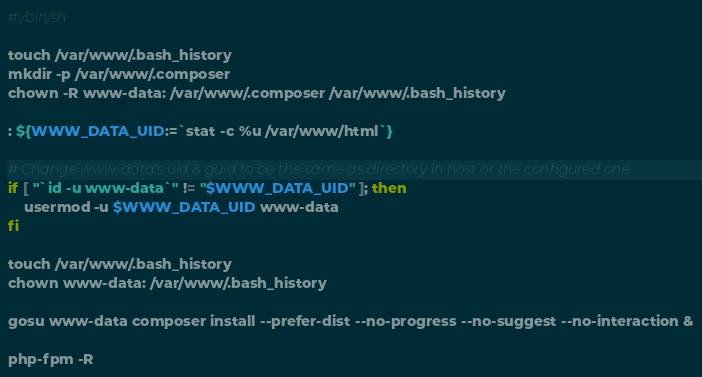Convert code to text. <code><loc_0><loc_0><loc_500><loc_500><_Bash_>#!/bin/sh

touch /var/www/.bash_history
mkdir -p /var/www/.composer
chown -R www-data: /var/www/.composer /var/www/.bash_history

: ${WWW_DATA_UID:=`stat -c %u /var/www/html`}

# Change www-data's uid & guid to be the same as directory in host or the configured one
if [ "`id -u www-data`" != "$WWW_DATA_UID" ]; then
    usermod -u $WWW_DATA_UID www-data
fi

touch /var/www/.bash_history
chown www-data: /var/www/.bash_history

gosu www-data composer install --prefer-dist --no-progress --no-suggest --no-interaction &

php-fpm -R
</code> 